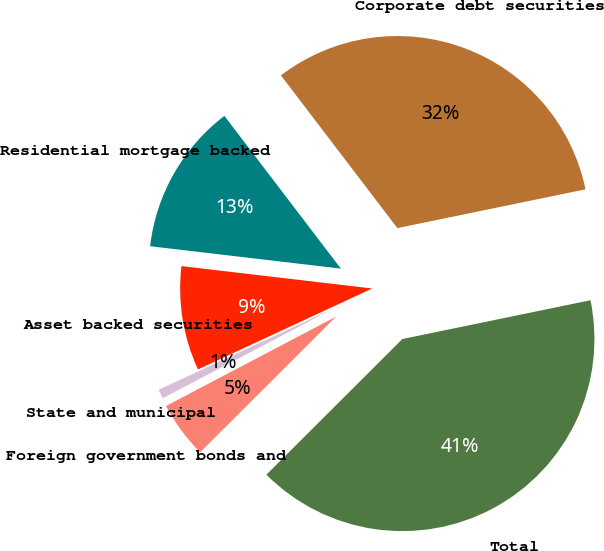<chart> <loc_0><loc_0><loc_500><loc_500><pie_chart><fcel>Corporate debt securities<fcel>Residential mortgage backed<fcel>Asset backed securities<fcel>State and municipal<fcel>Foreign government bonds and<fcel>Total<nl><fcel>32.13%<fcel>12.77%<fcel>8.78%<fcel>0.78%<fcel>4.78%<fcel>40.75%<nl></chart> 